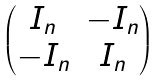<formula> <loc_0><loc_0><loc_500><loc_500>\begin{pmatrix} I _ { n } & - I _ { n } \\ - I _ { n } & I _ { n } \end{pmatrix}</formula> 